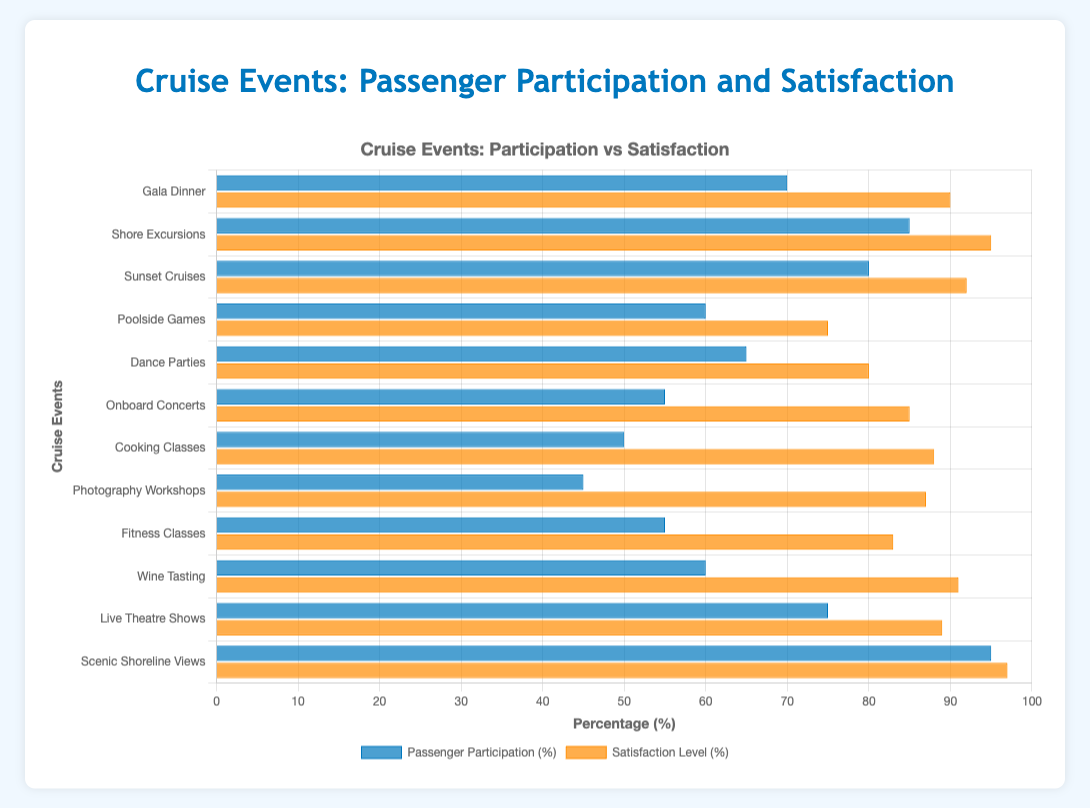Which event has the highest passenger participation? To identify the event with the highest passenger participation, locate the longest blue bar on the graph. This represents the event with the highest participation rate.
Answer: Scenic Shoreline Views Which event has a passenger participation rate equal to or below 50%? To find events with participation rates equal to or below 50%, look for the blue bars that stop at or before the 50% mark along the x-axis.
Answer: Photography Workshops, Cooking Classes How does passenger satisfaction for onboard concerts compare to fitness classes? Compare the lengths of the orange bars for 'Onboard Concerts' and 'Fitness Classes.' The longer bar indicates higher satisfaction. Both satisfaction levels can be compared directly as indicated by the bar lengths.
Answer: Onboard Concerts have higher satisfaction What is the difference in passenger participation between Poolside Games and Dance Parties? Locate the blue bars for both events, read their values, and subtract the smaller from the larger: 60% (Poolside Games) - 65% (Dance Parties).
Answer: 5% Which two events have the closest satisfaction levels? Compare the lengths of the orange bars to find events with nearly the same length, indicating close satisfaction rates. 'Gala Dinner' and 'Live Theatre Shows' have close satisfaction levels: 90% and 89% respectively.
Answer: Gala Dinner and Live Theatre Shows What is the average satisfaction level of the three events with the highest participation rates? First identify the events with the highest participation rates: 'Scenic Shoreline Views' (95%), 'Shore Excursions' (85%), and 'Sunset Cruises' (80%). Then calculate their satisfaction level average: (97 + 95 + 92) / 3.
Answer: 94.67% Which event has the longest orange bar, and what does it indicate? Look for the longest orange bar on the graph; this represents the highest satisfaction level. The longest bar belongs to 'Scenic Shoreline Views,' indicating the highest satisfaction.
Answer: Scenic Shoreline Views What is the combined passenger participation for Shore Excursions, Sunset Cruises, and Dance Parties? Add the participation rates of Shore Excursions (85%), Sunset Cruises (80%), and Dance Parties (65%): 85 + 80 + 65.
Answer: 230% Which event has a higher passenger participation rate, Wine Tasting or Fitness Classes? Compare the blue bars for 'Wine Tasting' and 'Fitness Classes.' The longer bar indicates higher participation rates.
Answer: Wine Tasting 